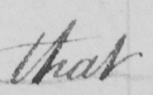What is written in this line of handwriting? that 